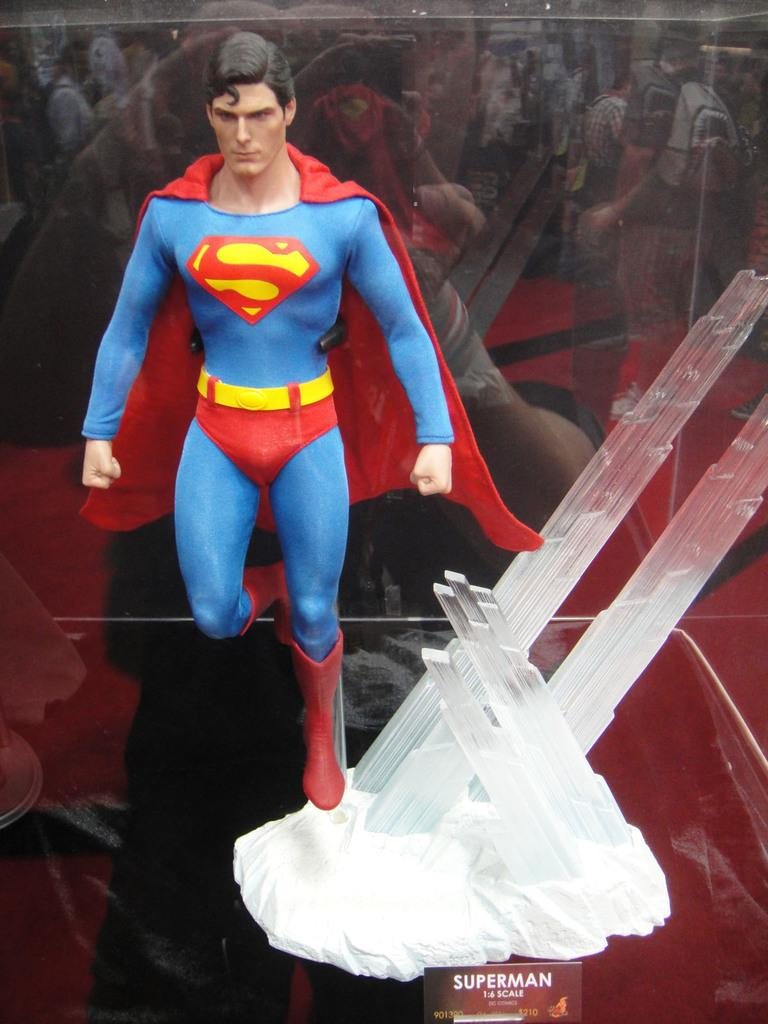What type of object can be seen in the image? There is a toy in the image. What other object is present in the image? There is a board in the image. Can you describe the object that is inside a glass box? There is an object in a glass box in the image. What can be seen in the reflection of the image? There is a reflection of a group of people in the image. What direction is the toy facing in the image? The direction the toy is facing cannot be determined from the image, as it is not mentioned in the facts. --- Facts: 1. There is a car in the image. 2. The car is red. 3. There are people in the car. 4. The car has four wheels. 5. The car has a license plate. Absurd Topics: ocean, bird, mountain Conversation: What type of vehicle is in the image? There is a car in the image. What color is the car? The car is red. Who is inside the car? There are people in the car. How many wheels does the car have? The car has four wheels. Is there any identification on the car? Yes, the car has a license plate. Reasoning: Let's think step by step in order to produce the conversation. We start by identifying the main subject in the image, which is the car. Then, we expand the conversation to include other important details about the car, such as its color, the presence of people inside, the number of wheels, and the license plate. Each question is designed to elicit a specific detail about the image that is known from the provided facts. Absurd Question/Answer: Can you see any mountains in the background of the image? There is no mention of mountains in the image, so it cannot be determined if they are present or not. 